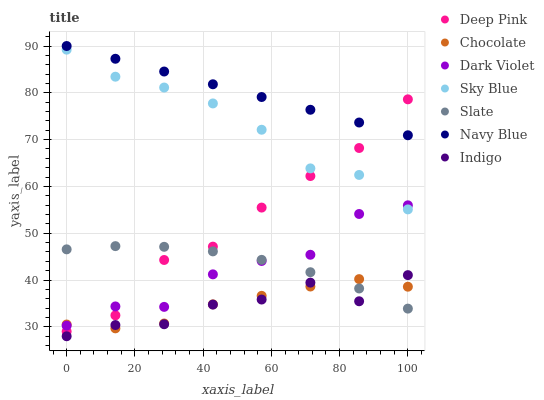Does Indigo have the minimum area under the curve?
Answer yes or no. Yes. Does Navy Blue have the maximum area under the curve?
Answer yes or no. Yes. Does Navy Blue have the minimum area under the curve?
Answer yes or no. No. Does Indigo have the maximum area under the curve?
Answer yes or no. No. Is Navy Blue the smoothest?
Answer yes or no. Yes. Is Dark Violet the roughest?
Answer yes or no. Yes. Is Indigo the smoothest?
Answer yes or no. No. Is Indigo the roughest?
Answer yes or no. No. Does Indigo have the lowest value?
Answer yes or no. Yes. Does Navy Blue have the lowest value?
Answer yes or no. No. Does Navy Blue have the highest value?
Answer yes or no. Yes. Does Indigo have the highest value?
Answer yes or no. No. Is Indigo less than Sky Blue?
Answer yes or no. Yes. Is Navy Blue greater than Dark Violet?
Answer yes or no. Yes. Does Deep Pink intersect Dark Violet?
Answer yes or no. Yes. Is Deep Pink less than Dark Violet?
Answer yes or no. No. Is Deep Pink greater than Dark Violet?
Answer yes or no. No. Does Indigo intersect Sky Blue?
Answer yes or no. No. 